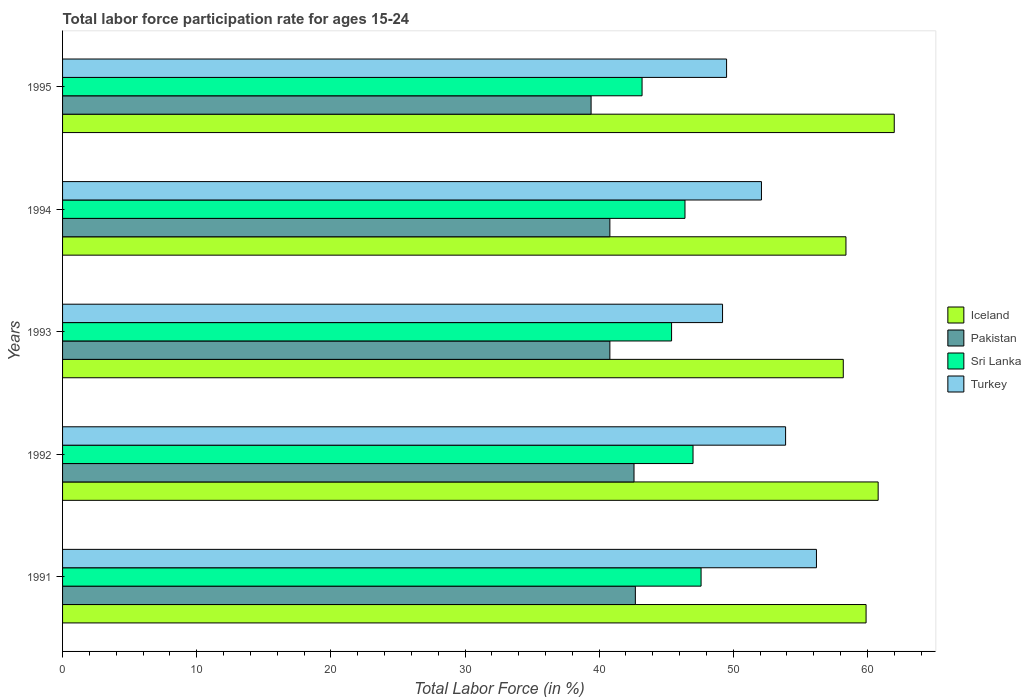How many different coloured bars are there?
Offer a very short reply. 4. How many groups of bars are there?
Ensure brevity in your answer.  5. What is the labor force participation rate in Sri Lanka in 1994?
Your answer should be very brief. 46.4. Across all years, what is the maximum labor force participation rate in Pakistan?
Ensure brevity in your answer.  42.7. Across all years, what is the minimum labor force participation rate in Sri Lanka?
Your answer should be compact. 43.2. In which year was the labor force participation rate in Turkey maximum?
Give a very brief answer. 1991. What is the total labor force participation rate in Turkey in the graph?
Ensure brevity in your answer.  260.9. What is the difference between the labor force participation rate in Iceland in 1992 and the labor force participation rate in Sri Lanka in 1991?
Keep it short and to the point. 13.2. What is the average labor force participation rate in Pakistan per year?
Provide a short and direct response. 41.26. In the year 1994, what is the difference between the labor force participation rate in Turkey and labor force participation rate in Iceland?
Make the answer very short. -6.3. What is the ratio of the labor force participation rate in Pakistan in 1991 to that in 1995?
Your answer should be compact. 1.08. Is the labor force participation rate in Turkey in 1992 less than that in 1994?
Offer a very short reply. No. Is the difference between the labor force participation rate in Turkey in 1992 and 1995 greater than the difference between the labor force participation rate in Iceland in 1992 and 1995?
Give a very brief answer. Yes. What is the difference between the highest and the second highest labor force participation rate in Pakistan?
Give a very brief answer. 0.1. What is the difference between the highest and the lowest labor force participation rate in Sri Lanka?
Offer a very short reply. 4.4. In how many years, is the labor force participation rate in Iceland greater than the average labor force participation rate in Iceland taken over all years?
Keep it short and to the point. 3. Is the sum of the labor force participation rate in Iceland in 1993 and 1994 greater than the maximum labor force participation rate in Pakistan across all years?
Make the answer very short. Yes. Is it the case that in every year, the sum of the labor force participation rate in Sri Lanka and labor force participation rate in Pakistan is greater than the sum of labor force participation rate in Turkey and labor force participation rate in Iceland?
Provide a succinct answer. No. What does the 1st bar from the top in 1994 represents?
Give a very brief answer. Turkey. What does the 2nd bar from the bottom in 1995 represents?
Ensure brevity in your answer.  Pakistan. Is it the case that in every year, the sum of the labor force participation rate in Pakistan and labor force participation rate in Iceland is greater than the labor force participation rate in Turkey?
Make the answer very short. Yes. How many bars are there?
Ensure brevity in your answer.  20. How many years are there in the graph?
Your answer should be very brief. 5. Are the values on the major ticks of X-axis written in scientific E-notation?
Ensure brevity in your answer.  No. Does the graph contain any zero values?
Provide a short and direct response. No. What is the title of the graph?
Ensure brevity in your answer.  Total labor force participation rate for ages 15-24. What is the Total Labor Force (in %) of Iceland in 1991?
Provide a short and direct response. 59.9. What is the Total Labor Force (in %) of Pakistan in 1991?
Provide a succinct answer. 42.7. What is the Total Labor Force (in %) in Sri Lanka in 1991?
Give a very brief answer. 47.6. What is the Total Labor Force (in %) of Turkey in 1991?
Provide a short and direct response. 56.2. What is the Total Labor Force (in %) in Iceland in 1992?
Offer a terse response. 60.8. What is the Total Labor Force (in %) in Pakistan in 1992?
Ensure brevity in your answer.  42.6. What is the Total Labor Force (in %) of Sri Lanka in 1992?
Your answer should be compact. 47. What is the Total Labor Force (in %) of Turkey in 1992?
Offer a very short reply. 53.9. What is the Total Labor Force (in %) in Iceland in 1993?
Make the answer very short. 58.2. What is the Total Labor Force (in %) of Pakistan in 1993?
Provide a succinct answer. 40.8. What is the Total Labor Force (in %) of Sri Lanka in 1993?
Offer a very short reply. 45.4. What is the Total Labor Force (in %) in Turkey in 1993?
Make the answer very short. 49.2. What is the Total Labor Force (in %) in Iceland in 1994?
Provide a succinct answer. 58.4. What is the Total Labor Force (in %) of Pakistan in 1994?
Provide a succinct answer. 40.8. What is the Total Labor Force (in %) in Sri Lanka in 1994?
Offer a terse response. 46.4. What is the Total Labor Force (in %) in Turkey in 1994?
Your answer should be very brief. 52.1. What is the Total Labor Force (in %) in Iceland in 1995?
Give a very brief answer. 62. What is the Total Labor Force (in %) in Pakistan in 1995?
Give a very brief answer. 39.4. What is the Total Labor Force (in %) in Sri Lanka in 1995?
Provide a succinct answer. 43.2. What is the Total Labor Force (in %) in Turkey in 1995?
Make the answer very short. 49.5. Across all years, what is the maximum Total Labor Force (in %) in Iceland?
Offer a terse response. 62. Across all years, what is the maximum Total Labor Force (in %) of Pakistan?
Provide a succinct answer. 42.7. Across all years, what is the maximum Total Labor Force (in %) of Sri Lanka?
Provide a short and direct response. 47.6. Across all years, what is the maximum Total Labor Force (in %) of Turkey?
Provide a succinct answer. 56.2. Across all years, what is the minimum Total Labor Force (in %) in Iceland?
Keep it short and to the point. 58.2. Across all years, what is the minimum Total Labor Force (in %) in Pakistan?
Your answer should be compact. 39.4. Across all years, what is the minimum Total Labor Force (in %) in Sri Lanka?
Your response must be concise. 43.2. Across all years, what is the minimum Total Labor Force (in %) of Turkey?
Your answer should be very brief. 49.2. What is the total Total Labor Force (in %) in Iceland in the graph?
Give a very brief answer. 299.3. What is the total Total Labor Force (in %) in Pakistan in the graph?
Give a very brief answer. 206.3. What is the total Total Labor Force (in %) in Sri Lanka in the graph?
Give a very brief answer. 229.6. What is the total Total Labor Force (in %) in Turkey in the graph?
Your answer should be compact. 260.9. What is the difference between the Total Labor Force (in %) of Sri Lanka in 1991 and that in 1992?
Provide a short and direct response. 0.6. What is the difference between the Total Labor Force (in %) in Turkey in 1991 and that in 1992?
Offer a very short reply. 2.3. What is the difference between the Total Labor Force (in %) in Iceland in 1991 and that in 1993?
Ensure brevity in your answer.  1.7. What is the difference between the Total Labor Force (in %) in Pakistan in 1991 and that in 1993?
Your answer should be very brief. 1.9. What is the difference between the Total Labor Force (in %) of Iceland in 1991 and that in 1995?
Provide a succinct answer. -2.1. What is the difference between the Total Labor Force (in %) in Pakistan in 1991 and that in 1995?
Offer a terse response. 3.3. What is the difference between the Total Labor Force (in %) in Iceland in 1992 and that in 1993?
Give a very brief answer. 2.6. What is the difference between the Total Labor Force (in %) in Pakistan in 1992 and that in 1993?
Your answer should be very brief. 1.8. What is the difference between the Total Labor Force (in %) in Sri Lanka in 1992 and that in 1993?
Provide a succinct answer. 1.6. What is the difference between the Total Labor Force (in %) in Turkey in 1992 and that in 1993?
Make the answer very short. 4.7. What is the difference between the Total Labor Force (in %) of Pakistan in 1992 and that in 1994?
Keep it short and to the point. 1.8. What is the difference between the Total Labor Force (in %) of Turkey in 1992 and that in 1994?
Provide a succinct answer. 1.8. What is the difference between the Total Labor Force (in %) of Sri Lanka in 1992 and that in 1995?
Keep it short and to the point. 3.8. What is the difference between the Total Labor Force (in %) in Turkey in 1992 and that in 1995?
Your answer should be compact. 4.4. What is the difference between the Total Labor Force (in %) of Iceland in 1993 and that in 1995?
Keep it short and to the point. -3.8. What is the difference between the Total Labor Force (in %) in Iceland in 1994 and that in 1995?
Your answer should be very brief. -3.6. What is the difference between the Total Labor Force (in %) of Pakistan in 1994 and that in 1995?
Give a very brief answer. 1.4. What is the difference between the Total Labor Force (in %) in Sri Lanka in 1994 and that in 1995?
Ensure brevity in your answer.  3.2. What is the difference between the Total Labor Force (in %) of Turkey in 1994 and that in 1995?
Offer a very short reply. 2.6. What is the difference between the Total Labor Force (in %) in Iceland in 1991 and the Total Labor Force (in %) in Pakistan in 1992?
Provide a short and direct response. 17.3. What is the difference between the Total Labor Force (in %) in Iceland in 1991 and the Total Labor Force (in %) in Sri Lanka in 1992?
Your response must be concise. 12.9. What is the difference between the Total Labor Force (in %) of Iceland in 1991 and the Total Labor Force (in %) of Turkey in 1992?
Provide a succinct answer. 6. What is the difference between the Total Labor Force (in %) in Pakistan in 1991 and the Total Labor Force (in %) in Turkey in 1992?
Your answer should be very brief. -11.2. What is the difference between the Total Labor Force (in %) of Sri Lanka in 1991 and the Total Labor Force (in %) of Turkey in 1992?
Your answer should be compact. -6.3. What is the difference between the Total Labor Force (in %) in Iceland in 1991 and the Total Labor Force (in %) in Pakistan in 1993?
Ensure brevity in your answer.  19.1. What is the difference between the Total Labor Force (in %) of Iceland in 1991 and the Total Labor Force (in %) of Turkey in 1993?
Offer a very short reply. 10.7. What is the difference between the Total Labor Force (in %) in Iceland in 1991 and the Total Labor Force (in %) in Pakistan in 1994?
Offer a very short reply. 19.1. What is the difference between the Total Labor Force (in %) in Iceland in 1991 and the Total Labor Force (in %) in Sri Lanka in 1994?
Your answer should be compact. 13.5. What is the difference between the Total Labor Force (in %) in Sri Lanka in 1991 and the Total Labor Force (in %) in Turkey in 1994?
Provide a succinct answer. -4.5. What is the difference between the Total Labor Force (in %) of Iceland in 1991 and the Total Labor Force (in %) of Pakistan in 1995?
Offer a terse response. 20.5. What is the difference between the Total Labor Force (in %) of Iceland in 1992 and the Total Labor Force (in %) of Sri Lanka in 1993?
Give a very brief answer. 15.4. What is the difference between the Total Labor Force (in %) in Iceland in 1992 and the Total Labor Force (in %) in Turkey in 1993?
Your response must be concise. 11.6. What is the difference between the Total Labor Force (in %) in Iceland in 1992 and the Total Labor Force (in %) in Sri Lanka in 1994?
Keep it short and to the point. 14.4. What is the difference between the Total Labor Force (in %) of Pakistan in 1992 and the Total Labor Force (in %) of Turkey in 1994?
Your response must be concise. -9.5. What is the difference between the Total Labor Force (in %) of Sri Lanka in 1992 and the Total Labor Force (in %) of Turkey in 1994?
Give a very brief answer. -5.1. What is the difference between the Total Labor Force (in %) in Iceland in 1992 and the Total Labor Force (in %) in Pakistan in 1995?
Your answer should be compact. 21.4. What is the difference between the Total Labor Force (in %) in Pakistan in 1992 and the Total Labor Force (in %) in Turkey in 1995?
Give a very brief answer. -6.9. What is the difference between the Total Labor Force (in %) in Sri Lanka in 1992 and the Total Labor Force (in %) in Turkey in 1995?
Provide a short and direct response. -2.5. What is the difference between the Total Labor Force (in %) of Iceland in 1993 and the Total Labor Force (in %) of Sri Lanka in 1994?
Offer a very short reply. 11.8. What is the difference between the Total Labor Force (in %) in Iceland in 1993 and the Total Labor Force (in %) in Turkey in 1994?
Offer a very short reply. 6.1. What is the difference between the Total Labor Force (in %) in Pakistan in 1993 and the Total Labor Force (in %) in Sri Lanka in 1994?
Offer a very short reply. -5.6. What is the difference between the Total Labor Force (in %) of Iceland in 1993 and the Total Labor Force (in %) of Pakistan in 1995?
Give a very brief answer. 18.8. What is the difference between the Total Labor Force (in %) in Iceland in 1993 and the Total Labor Force (in %) in Turkey in 1995?
Ensure brevity in your answer.  8.7. What is the difference between the Total Labor Force (in %) of Pakistan in 1993 and the Total Labor Force (in %) of Sri Lanka in 1995?
Your answer should be very brief. -2.4. What is the difference between the Total Labor Force (in %) of Iceland in 1994 and the Total Labor Force (in %) of Sri Lanka in 1995?
Make the answer very short. 15.2. What is the difference between the Total Labor Force (in %) in Iceland in 1994 and the Total Labor Force (in %) in Turkey in 1995?
Give a very brief answer. 8.9. What is the difference between the Total Labor Force (in %) in Pakistan in 1994 and the Total Labor Force (in %) in Sri Lanka in 1995?
Your answer should be very brief. -2.4. What is the difference between the Total Labor Force (in %) in Pakistan in 1994 and the Total Labor Force (in %) in Turkey in 1995?
Provide a short and direct response. -8.7. What is the difference between the Total Labor Force (in %) of Sri Lanka in 1994 and the Total Labor Force (in %) of Turkey in 1995?
Your answer should be very brief. -3.1. What is the average Total Labor Force (in %) of Iceland per year?
Provide a succinct answer. 59.86. What is the average Total Labor Force (in %) of Pakistan per year?
Your answer should be compact. 41.26. What is the average Total Labor Force (in %) of Sri Lanka per year?
Make the answer very short. 45.92. What is the average Total Labor Force (in %) of Turkey per year?
Offer a terse response. 52.18. In the year 1991, what is the difference between the Total Labor Force (in %) of Iceland and Total Labor Force (in %) of Pakistan?
Ensure brevity in your answer.  17.2. In the year 1991, what is the difference between the Total Labor Force (in %) in Iceland and Total Labor Force (in %) in Sri Lanka?
Keep it short and to the point. 12.3. In the year 1991, what is the difference between the Total Labor Force (in %) in Iceland and Total Labor Force (in %) in Turkey?
Your answer should be compact. 3.7. In the year 1991, what is the difference between the Total Labor Force (in %) of Pakistan and Total Labor Force (in %) of Sri Lanka?
Give a very brief answer. -4.9. In the year 1991, what is the difference between the Total Labor Force (in %) of Pakistan and Total Labor Force (in %) of Turkey?
Your answer should be compact. -13.5. In the year 1991, what is the difference between the Total Labor Force (in %) of Sri Lanka and Total Labor Force (in %) of Turkey?
Give a very brief answer. -8.6. In the year 1992, what is the difference between the Total Labor Force (in %) in Iceland and Total Labor Force (in %) in Pakistan?
Offer a very short reply. 18.2. In the year 1992, what is the difference between the Total Labor Force (in %) in Iceland and Total Labor Force (in %) in Sri Lanka?
Your answer should be compact. 13.8. In the year 1992, what is the difference between the Total Labor Force (in %) of Iceland and Total Labor Force (in %) of Turkey?
Offer a very short reply. 6.9. In the year 1992, what is the difference between the Total Labor Force (in %) in Pakistan and Total Labor Force (in %) in Sri Lanka?
Keep it short and to the point. -4.4. In the year 1992, what is the difference between the Total Labor Force (in %) of Pakistan and Total Labor Force (in %) of Turkey?
Keep it short and to the point. -11.3. In the year 1993, what is the difference between the Total Labor Force (in %) in Iceland and Total Labor Force (in %) in Sri Lanka?
Ensure brevity in your answer.  12.8. In the year 1993, what is the difference between the Total Labor Force (in %) of Iceland and Total Labor Force (in %) of Turkey?
Give a very brief answer. 9. In the year 1993, what is the difference between the Total Labor Force (in %) of Pakistan and Total Labor Force (in %) of Sri Lanka?
Your answer should be compact. -4.6. In the year 1994, what is the difference between the Total Labor Force (in %) in Iceland and Total Labor Force (in %) in Pakistan?
Keep it short and to the point. 17.6. In the year 1994, what is the difference between the Total Labor Force (in %) of Iceland and Total Labor Force (in %) of Sri Lanka?
Ensure brevity in your answer.  12. In the year 1994, what is the difference between the Total Labor Force (in %) of Iceland and Total Labor Force (in %) of Turkey?
Ensure brevity in your answer.  6.3. In the year 1994, what is the difference between the Total Labor Force (in %) of Pakistan and Total Labor Force (in %) of Sri Lanka?
Give a very brief answer. -5.6. In the year 1995, what is the difference between the Total Labor Force (in %) of Iceland and Total Labor Force (in %) of Pakistan?
Give a very brief answer. 22.6. In the year 1995, what is the difference between the Total Labor Force (in %) of Iceland and Total Labor Force (in %) of Turkey?
Provide a short and direct response. 12.5. In the year 1995, what is the difference between the Total Labor Force (in %) of Pakistan and Total Labor Force (in %) of Sri Lanka?
Provide a short and direct response. -3.8. In the year 1995, what is the difference between the Total Labor Force (in %) of Sri Lanka and Total Labor Force (in %) of Turkey?
Your answer should be very brief. -6.3. What is the ratio of the Total Labor Force (in %) in Iceland in 1991 to that in 1992?
Provide a short and direct response. 0.99. What is the ratio of the Total Labor Force (in %) in Pakistan in 1991 to that in 1992?
Provide a succinct answer. 1. What is the ratio of the Total Labor Force (in %) in Sri Lanka in 1991 to that in 1992?
Ensure brevity in your answer.  1.01. What is the ratio of the Total Labor Force (in %) of Turkey in 1991 to that in 1992?
Offer a terse response. 1.04. What is the ratio of the Total Labor Force (in %) of Iceland in 1991 to that in 1993?
Offer a very short reply. 1.03. What is the ratio of the Total Labor Force (in %) of Pakistan in 1991 to that in 1993?
Ensure brevity in your answer.  1.05. What is the ratio of the Total Labor Force (in %) in Sri Lanka in 1991 to that in 1993?
Your answer should be compact. 1.05. What is the ratio of the Total Labor Force (in %) in Turkey in 1991 to that in 1993?
Your answer should be very brief. 1.14. What is the ratio of the Total Labor Force (in %) in Iceland in 1991 to that in 1994?
Ensure brevity in your answer.  1.03. What is the ratio of the Total Labor Force (in %) of Pakistan in 1991 to that in 1994?
Keep it short and to the point. 1.05. What is the ratio of the Total Labor Force (in %) of Sri Lanka in 1991 to that in 1994?
Your response must be concise. 1.03. What is the ratio of the Total Labor Force (in %) of Turkey in 1991 to that in 1994?
Keep it short and to the point. 1.08. What is the ratio of the Total Labor Force (in %) in Iceland in 1991 to that in 1995?
Offer a terse response. 0.97. What is the ratio of the Total Labor Force (in %) in Pakistan in 1991 to that in 1995?
Your answer should be compact. 1.08. What is the ratio of the Total Labor Force (in %) of Sri Lanka in 1991 to that in 1995?
Keep it short and to the point. 1.1. What is the ratio of the Total Labor Force (in %) in Turkey in 1991 to that in 1995?
Your answer should be very brief. 1.14. What is the ratio of the Total Labor Force (in %) of Iceland in 1992 to that in 1993?
Ensure brevity in your answer.  1.04. What is the ratio of the Total Labor Force (in %) in Pakistan in 1992 to that in 1993?
Make the answer very short. 1.04. What is the ratio of the Total Labor Force (in %) of Sri Lanka in 1992 to that in 1993?
Offer a terse response. 1.04. What is the ratio of the Total Labor Force (in %) in Turkey in 1992 to that in 1993?
Provide a short and direct response. 1.1. What is the ratio of the Total Labor Force (in %) in Iceland in 1992 to that in 1994?
Provide a short and direct response. 1.04. What is the ratio of the Total Labor Force (in %) of Pakistan in 1992 to that in 1994?
Keep it short and to the point. 1.04. What is the ratio of the Total Labor Force (in %) in Sri Lanka in 1992 to that in 1994?
Keep it short and to the point. 1.01. What is the ratio of the Total Labor Force (in %) in Turkey in 1992 to that in 1994?
Keep it short and to the point. 1.03. What is the ratio of the Total Labor Force (in %) of Iceland in 1992 to that in 1995?
Keep it short and to the point. 0.98. What is the ratio of the Total Labor Force (in %) in Pakistan in 1992 to that in 1995?
Offer a very short reply. 1.08. What is the ratio of the Total Labor Force (in %) in Sri Lanka in 1992 to that in 1995?
Make the answer very short. 1.09. What is the ratio of the Total Labor Force (in %) in Turkey in 1992 to that in 1995?
Your answer should be very brief. 1.09. What is the ratio of the Total Labor Force (in %) of Sri Lanka in 1993 to that in 1994?
Ensure brevity in your answer.  0.98. What is the ratio of the Total Labor Force (in %) in Turkey in 1993 to that in 1994?
Provide a succinct answer. 0.94. What is the ratio of the Total Labor Force (in %) of Iceland in 1993 to that in 1995?
Ensure brevity in your answer.  0.94. What is the ratio of the Total Labor Force (in %) of Pakistan in 1993 to that in 1995?
Your answer should be compact. 1.04. What is the ratio of the Total Labor Force (in %) of Sri Lanka in 1993 to that in 1995?
Ensure brevity in your answer.  1.05. What is the ratio of the Total Labor Force (in %) of Iceland in 1994 to that in 1995?
Offer a terse response. 0.94. What is the ratio of the Total Labor Force (in %) in Pakistan in 1994 to that in 1995?
Your answer should be compact. 1.04. What is the ratio of the Total Labor Force (in %) of Sri Lanka in 1994 to that in 1995?
Your response must be concise. 1.07. What is the ratio of the Total Labor Force (in %) of Turkey in 1994 to that in 1995?
Your response must be concise. 1.05. What is the difference between the highest and the lowest Total Labor Force (in %) of Iceland?
Provide a short and direct response. 3.8. What is the difference between the highest and the lowest Total Labor Force (in %) in Pakistan?
Your response must be concise. 3.3. What is the difference between the highest and the lowest Total Labor Force (in %) in Turkey?
Provide a succinct answer. 7. 